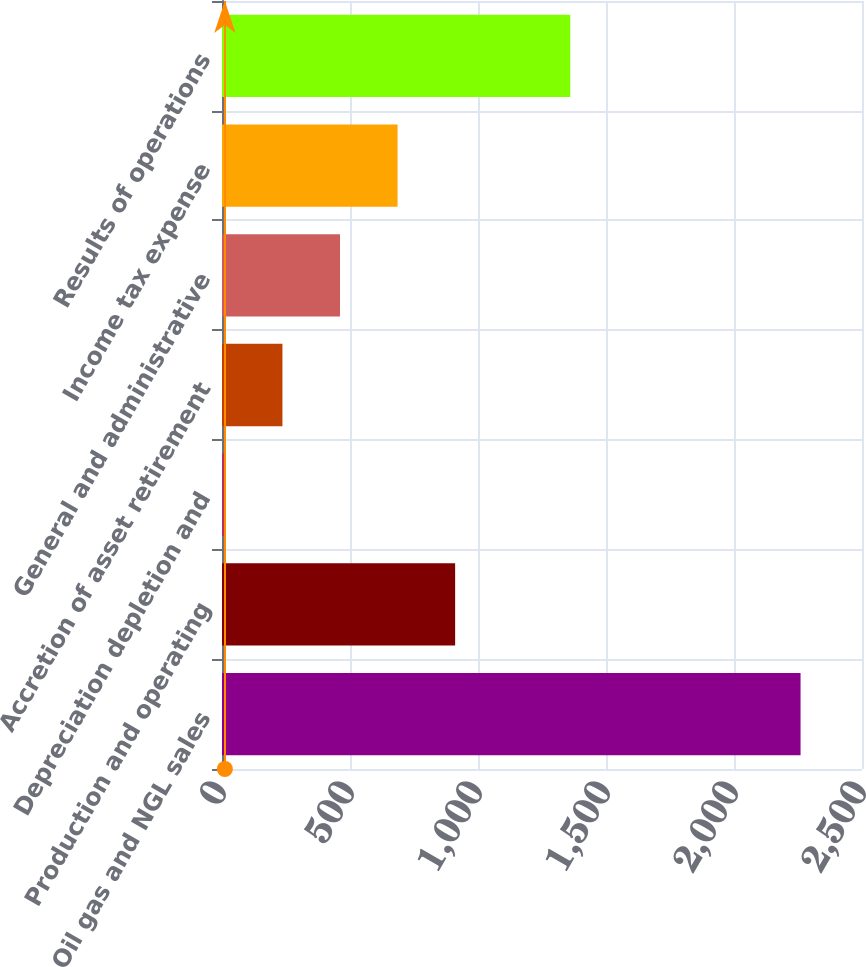<chart> <loc_0><loc_0><loc_500><loc_500><bar_chart><fcel>Oil gas and NGL sales<fcel>Production and operating<fcel>Depreciation depletion and<fcel>Accretion of asset retirement<fcel>General and administrative<fcel>Income tax expense<fcel>Results of operations<nl><fcel>2260<fcel>910.69<fcel>11.17<fcel>236.05<fcel>460.93<fcel>685.81<fcel>1360.45<nl></chart> 